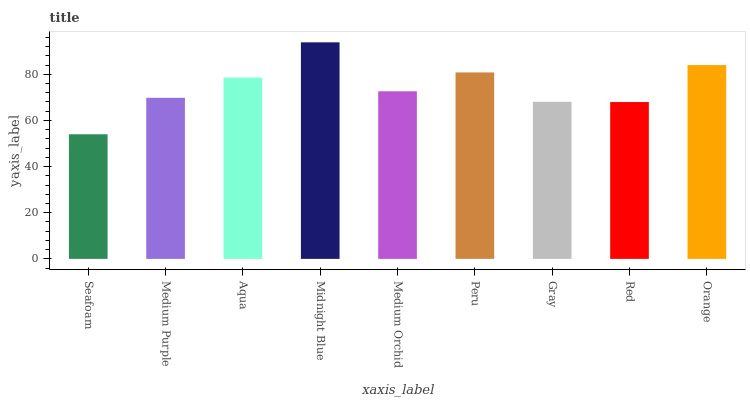Is Medium Purple the minimum?
Answer yes or no. No. Is Medium Purple the maximum?
Answer yes or no. No. Is Medium Purple greater than Seafoam?
Answer yes or no. Yes. Is Seafoam less than Medium Purple?
Answer yes or no. Yes. Is Seafoam greater than Medium Purple?
Answer yes or no. No. Is Medium Purple less than Seafoam?
Answer yes or no. No. Is Medium Orchid the high median?
Answer yes or no. Yes. Is Medium Orchid the low median?
Answer yes or no. Yes. Is Medium Purple the high median?
Answer yes or no. No. Is Midnight Blue the low median?
Answer yes or no. No. 